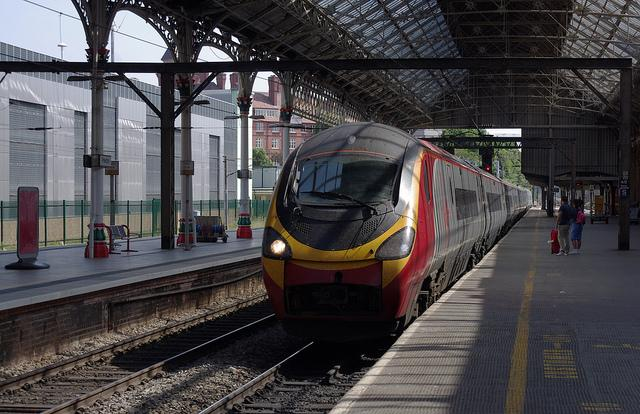Why are the people standing behind the yellow line? Please explain your reasoning. safety. The people want to be safe. 